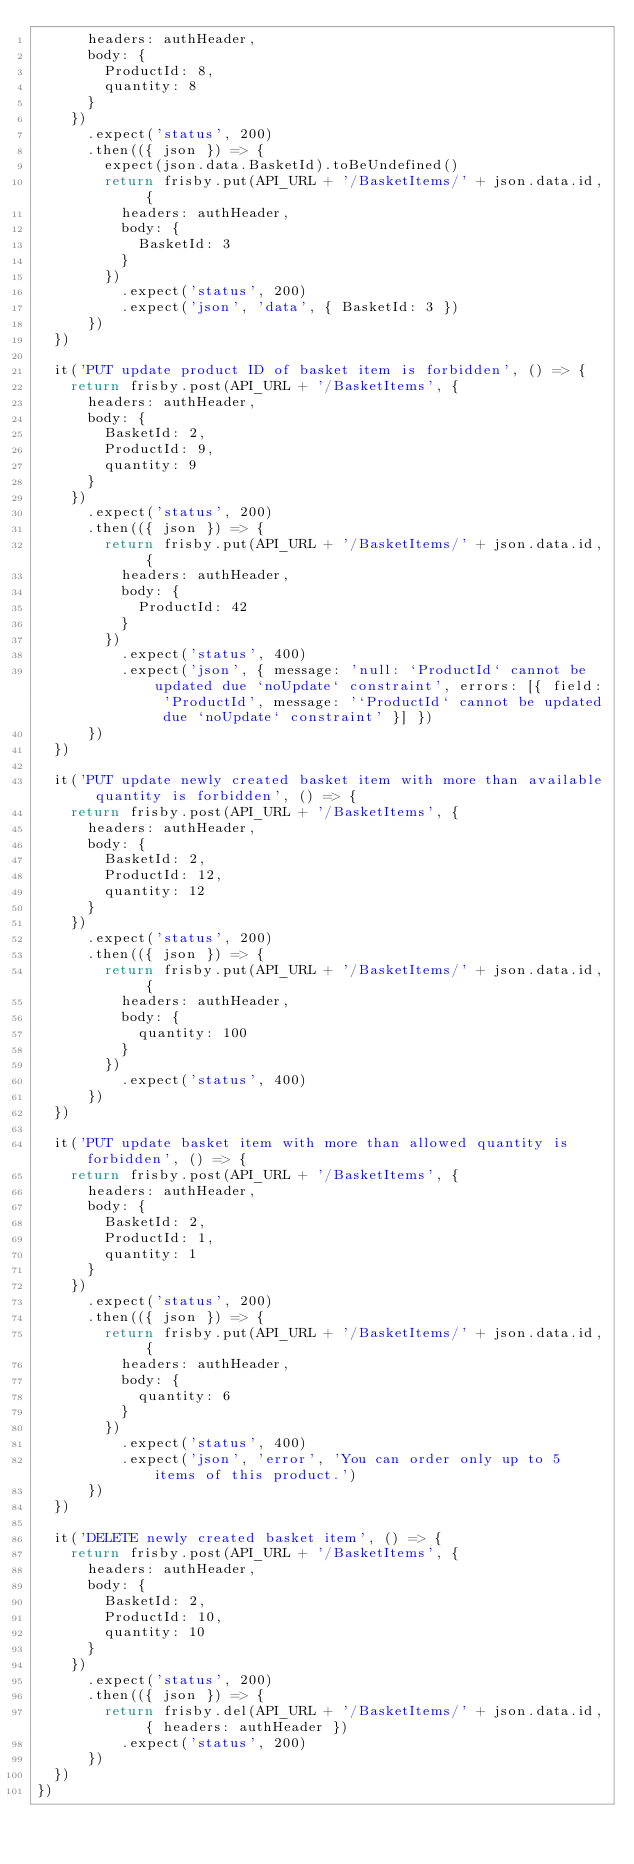<code> <loc_0><loc_0><loc_500><loc_500><_TypeScript_>      headers: authHeader,
      body: {
        ProductId: 8,
        quantity: 8
      }
    })
      .expect('status', 200)
      .then(({ json }) => {
        expect(json.data.BasketId).toBeUndefined()
        return frisby.put(API_URL + '/BasketItems/' + json.data.id, {
          headers: authHeader,
          body: {
            BasketId: 3
          }
        })
          .expect('status', 200)
          .expect('json', 'data', { BasketId: 3 })
      })
  })

  it('PUT update product ID of basket item is forbidden', () => {
    return frisby.post(API_URL + '/BasketItems', {
      headers: authHeader,
      body: {
        BasketId: 2,
        ProductId: 9,
        quantity: 9
      }
    })
      .expect('status', 200)
      .then(({ json }) => {
        return frisby.put(API_URL + '/BasketItems/' + json.data.id, {
          headers: authHeader,
          body: {
            ProductId: 42
          }
        })
          .expect('status', 400)
          .expect('json', { message: 'null: `ProductId` cannot be updated due `noUpdate` constraint', errors: [{ field: 'ProductId', message: '`ProductId` cannot be updated due `noUpdate` constraint' }] })
      })
  })

  it('PUT update newly created basket item with more than available quantity is forbidden', () => {
    return frisby.post(API_URL + '/BasketItems', {
      headers: authHeader,
      body: {
        BasketId: 2,
        ProductId: 12,
        quantity: 12
      }
    })
      .expect('status', 200)
      .then(({ json }) => {
        return frisby.put(API_URL + '/BasketItems/' + json.data.id, {
          headers: authHeader,
          body: {
            quantity: 100
          }
        })
          .expect('status', 400)
      })
  })

  it('PUT update basket item with more than allowed quantity is forbidden', () => {
    return frisby.post(API_URL + '/BasketItems', {
      headers: authHeader,
      body: {
        BasketId: 2,
        ProductId: 1,
        quantity: 1
      }
    })
      .expect('status', 200)
      .then(({ json }) => {
        return frisby.put(API_URL + '/BasketItems/' + json.data.id, {
          headers: authHeader,
          body: {
            quantity: 6
          }
        })
          .expect('status', 400)
          .expect('json', 'error', 'You can order only up to 5 items of this product.')
      })
  })

  it('DELETE newly created basket item', () => {
    return frisby.post(API_URL + '/BasketItems', {
      headers: authHeader,
      body: {
        BasketId: 2,
        ProductId: 10,
        quantity: 10
      }
    })
      .expect('status', 200)
      .then(({ json }) => {
        return frisby.del(API_URL + '/BasketItems/' + json.data.id, { headers: authHeader })
          .expect('status', 200)
      })
  })
})
</code> 